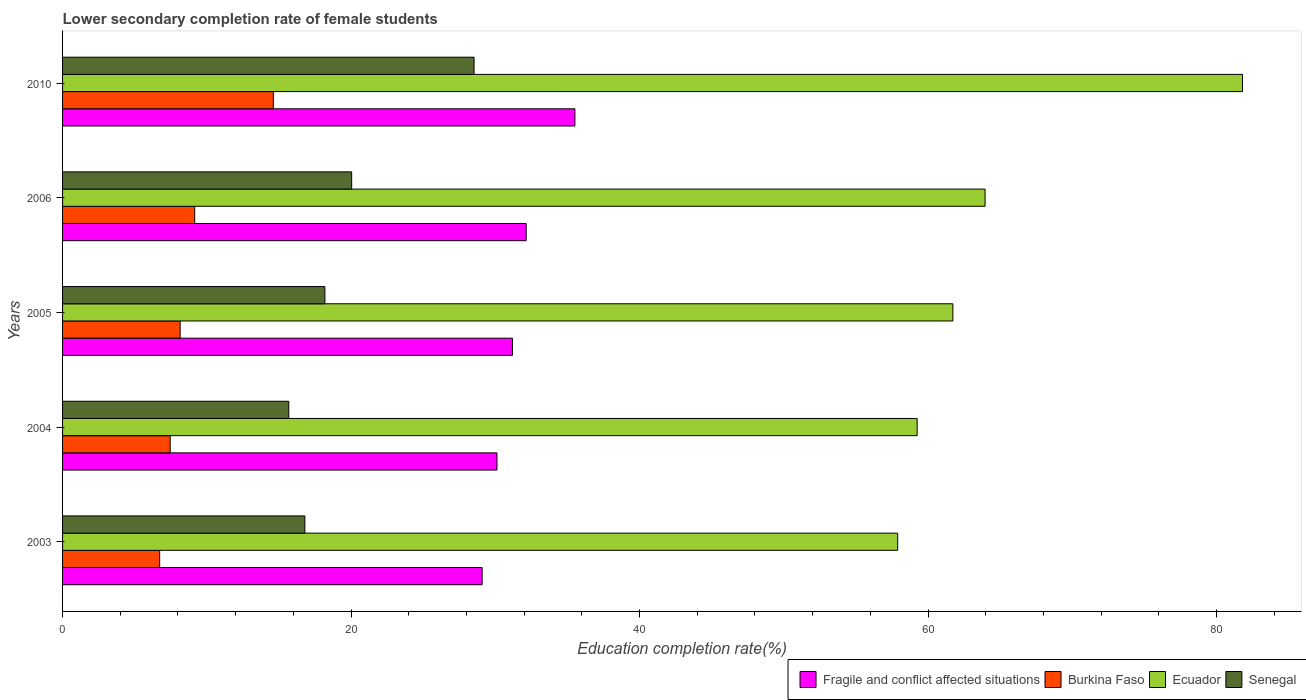How many different coloured bars are there?
Give a very brief answer. 4. How many groups of bars are there?
Your response must be concise. 5. Are the number of bars per tick equal to the number of legend labels?
Provide a succinct answer. Yes. How many bars are there on the 3rd tick from the bottom?
Your answer should be compact. 4. In how many cases, is the number of bars for a given year not equal to the number of legend labels?
Provide a succinct answer. 0. What is the lower secondary completion rate of female students in Burkina Faso in 2006?
Your answer should be very brief. 9.16. Across all years, what is the maximum lower secondary completion rate of female students in Burkina Faso?
Offer a very short reply. 14.61. Across all years, what is the minimum lower secondary completion rate of female students in Senegal?
Ensure brevity in your answer.  15.68. What is the total lower secondary completion rate of female students in Senegal in the graph?
Make the answer very short. 99.23. What is the difference between the lower secondary completion rate of female students in Burkina Faso in 2006 and that in 2010?
Offer a terse response. -5.45. What is the difference between the lower secondary completion rate of female students in Senegal in 2004 and the lower secondary completion rate of female students in Burkina Faso in 2006?
Keep it short and to the point. 6.52. What is the average lower secondary completion rate of female students in Burkina Faso per year?
Give a very brief answer. 9.22. In the year 2010, what is the difference between the lower secondary completion rate of female students in Burkina Faso and lower secondary completion rate of female students in Fragile and conflict affected situations?
Offer a terse response. -20.91. In how many years, is the lower secondary completion rate of female students in Senegal greater than 24 %?
Keep it short and to the point. 1. What is the ratio of the lower secondary completion rate of female students in Fragile and conflict affected situations in 2003 to that in 2010?
Give a very brief answer. 0.82. What is the difference between the highest and the second highest lower secondary completion rate of female students in Fragile and conflict affected situations?
Ensure brevity in your answer.  3.38. What is the difference between the highest and the lowest lower secondary completion rate of female students in Ecuador?
Your answer should be compact. 23.9. In how many years, is the lower secondary completion rate of female students in Senegal greater than the average lower secondary completion rate of female students in Senegal taken over all years?
Ensure brevity in your answer.  2. Is the sum of the lower secondary completion rate of female students in Burkina Faso in 2004 and 2006 greater than the maximum lower secondary completion rate of female students in Fragile and conflict affected situations across all years?
Make the answer very short. No. What does the 3rd bar from the top in 2010 represents?
Provide a short and direct response. Burkina Faso. What does the 1st bar from the bottom in 2003 represents?
Give a very brief answer. Fragile and conflict affected situations. How many bars are there?
Give a very brief answer. 20. What is the difference between two consecutive major ticks on the X-axis?
Make the answer very short. 20. Does the graph contain grids?
Your response must be concise. No. Where does the legend appear in the graph?
Offer a terse response. Bottom right. How are the legend labels stacked?
Offer a terse response. Horizontal. What is the title of the graph?
Your answer should be compact. Lower secondary completion rate of female students. Does "Guinea" appear as one of the legend labels in the graph?
Provide a short and direct response. No. What is the label or title of the X-axis?
Your answer should be very brief. Education completion rate(%). What is the Education completion rate(%) of Fragile and conflict affected situations in 2003?
Provide a succinct answer. 29.09. What is the Education completion rate(%) in Burkina Faso in 2003?
Your answer should be compact. 6.73. What is the Education completion rate(%) of Ecuador in 2003?
Offer a very short reply. 57.89. What is the Education completion rate(%) in Senegal in 2003?
Give a very brief answer. 16.8. What is the Education completion rate(%) in Fragile and conflict affected situations in 2004?
Keep it short and to the point. 30.11. What is the Education completion rate(%) of Burkina Faso in 2004?
Your response must be concise. 7.46. What is the Education completion rate(%) of Ecuador in 2004?
Your response must be concise. 59.24. What is the Education completion rate(%) of Senegal in 2004?
Give a very brief answer. 15.68. What is the Education completion rate(%) of Fragile and conflict affected situations in 2005?
Give a very brief answer. 31.19. What is the Education completion rate(%) in Burkina Faso in 2005?
Offer a very short reply. 8.15. What is the Education completion rate(%) in Ecuador in 2005?
Provide a succinct answer. 61.72. What is the Education completion rate(%) of Senegal in 2005?
Keep it short and to the point. 18.18. What is the Education completion rate(%) in Fragile and conflict affected situations in 2006?
Your response must be concise. 32.14. What is the Education completion rate(%) in Burkina Faso in 2006?
Make the answer very short. 9.16. What is the Education completion rate(%) in Ecuador in 2006?
Your answer should be very brief. 63.95. What is the Education completion rate(%) of Senegal in 2006?
Offer a very short reply. 20.04. What is the Education completion rate(%) of Fragile and conflict affected situations in 2010?
Offer a very short reply. 35.52. What is the Education completion rate(%) in Burkina Faso in 2010?
Make the answer very short. 14.61. What is the Education completion rate(%) of Ecuador in 2010?
Make the answer very short. 81.8. What is the Education completion rate(%) in Senegal in 2010?
Make the answer very short. 28.53. Across all years, what is the maximum Education completion rate(%) in Fragile and conflict affected situations?
Make the answer very short. 35.52. Across all years, what is the maximum Education completion rate(%) of Burkina Faso?
Your answer should be compact. 14.61. Across all years, what is the maximum Education completion rate(%) in Ecuador?
Offer a very short reply. 81.8. Across all years, what is the maximum Education completion rate(%) of Senegal?
Your answer should be very brief. 28.53. Across all years, what is the minimum Education completion rate(%) of Fragile and conflict affected situations?
Offer a terse response. 29.09. Across all years, what is the minimum Education completion rate(%) of Burkina Faso?
Provide a short and direct response. 6.73. Across all years, what is the minimum Education completion rate(%) of Ecuador?
Ensure brevity in your answer.  57.89. Across all years, what is the minimum Education completion rate(%) in Senegal?
Provide a short and direct response. 15.68. What is the total Education completion rate(%) in Fragile and conflict affected situations in the graph?
Make the answer very short. 158.04. What is the total Education completion rate(%) of Burkina Faso in the graph?
Make the answer very short. 46.11. What is the total Education completion rate(%) in Ecuador in the graph?
Your answer should be compact. 324.6. What is the total Education completion rate(%) of Senegal in the graph?
Your answer should be compact. 99.23. What is the difference between the Education completion rate(%) of Fragile and conflict affected situations in 2003 and that in 2004?
Offer a terse response. -1.03. What is the difference between the Education completion rate(%) in Burkina Faso in 2003 and that in 2004?
Your response must be concise. -0.73. What is the difference between the Education completion rate(%) of Ecuador in 2003 and that in 2004?
Make the answer very short. -1.35. What is the difference between the Education completion rate(%) of Senegal in 2003 and that in 2004?
Provide a succinct answer. 1.12. What is the difference between the Education completion rate(%) in Fragile and conflict affected situations in 2003 and that in 2005?
Offer a terse response. -2.1. What is the difference between the Education completion rate(%) in Burkina Faso in 2003 and that in 2005?
Provide a succinct answer. -1.42. What is the difference between the Education completion rate(%) of Ecuador in 2003 and that in 2005?
Give a very brief answer. -3.83. What is the difference between the Education completion rate(%) of Senegal in 2003 and that in 2005?
Provide a succinct answer. -1.39. What is the difference between the Education completion rate(%) of Fragile and conflict affected situations in 2003 and that in 2006?
Your response must be concise. -3.05. What is the difference between the Education completion rate(%) of Burkina Faso in 2003 and that in 2006?
Give a very brief answer. -2.43. What is the difference between the Education completion rate(%) of Ecuador in 2003 and that in 2006?
Provide a succinct answer. -6.06. What is the difference between the Education completion rate(%) in Senegal in 2003 and that in 2006?
Offer a terse response. -3.24. What is the difference between the Education completion rate(%) of Fragile and conflict affected situations in 2003 and that in 2010?
Offer a very short reply. -6.43. What is the difference between the Education completion rate(%) of Burkina Faso in 2003 and that in 2010?
Provide a short and direct response. -7.88. What is the difference between the Education completion rate(%) in Ecuador in 2003 and that in 2010?
Provide a short and direct response. -23.9. What is the difference between the Education completion rate(%) of Senegal in 2003 and that in 2010?
Your answer should be very brief. -11.73. What is the difference between the Education completion rate(%) of Fragile and conflict affected situations in 2004 and that in 2005?
Your response must be concise. -1.07. What is the difference between the Education completion rate(%) of Burkina Faso in 2004 and that in 2005?
Ensure brevity in your answer.  -0.69. What is the difference between the Education completion rate(%) in Ecuador in 2004 and that in 2005?
Offer a terse response. -2.48. What is the difference between the Education completion rate(%) in Senegal in 2004 and that in 2005?
Your response must be concise. -2.5. What is the difference between the Education completion rate(%) of Fragile and conflict affected situations in 2004 and that in 2006?
Offer a very short reply. -2.03. What is the difference between the Education completion rate(%) in Burkina Faso in 2004 and that in 2006?
Keep it short and to the point. -1.7. What is the difference between the Education completion rate(%) in Ecuador in 2004 and that in 2006?
Ensure brevity in your answer.  -4.71. What is the difference between the Education completion rate(%) of Senegal in 2004 and that in 2006?
Give a very brief answer. -4.36. What is the difference between the Education completion rate(%) of Fragile and conflict affected situations in 2004 and that in 2010?
Give a very brief answer. -5.4. What is the difference between the Education completion rate(%) in Burkina Faso in 2004 and that in 2010?
Keep it short and to the point. -7.15. What is the difference between the Education completion rate(%) in Ecuador in 2004 and that in 2010?
Your answer should be very brief. -22.55. What is the difference between the Education completion rate(%) in Senegal in 2004 and that in 2010?
Ensure brevity in your answer.  -12.84. What is the difference between the Education completion rate(%) of Fragile and conflict affected situations in 2005 and that in 2006?
Your response must be concise. -0.95. What is the difference between the Education completion rate(%) in Burkina Faso in 2005 and that in 2006?
Ensure brevity in your answer.  -1.01. What is the difference between the Education completion rate(%) of Ecuador in 2005 and that in 2006?
Your answer should be compact. -2.23. What is the difference between the Education completion rate(%) of Senegal in 2005 and that in 2006?
Your answer should be compact. -1.86. What is the difference between the Education completion rate(%) of Fragile and conflict affected situations in 2005 and that in 2010?
Your answer should be compact. -4.33. What is the difference between the Education completion rate(%) in Burkina Faso in 2005 and that in 2010?
Your answer should be very brief. -6.46. What is the difference between the Education completion rate(%) of Ecuador in 2005 and that in 2010?
Your answer should be very brief. -20.08. What is the difference between the Education completion rate(%) in Senegal in 2005 and that in 2010?
Your answer should be very brief. -10.34. What is the difference between the Education completion rate(%) of Fragile and conflict affected situations in 2006 and that in 2010?
Provide a succinct answer. -3.38. What is the difference between the Education completion rate(%) in Burkina Faso in 2006 and that in 2010?
Provide a short and direct response. -5.45. What is the difference between the Education completion rate(%) of Ecuador in 2006 and that in 2010?
Your response must be concise. -17.85. What is the difference between the Education completion rate(%) in Senegal in 2006 and that in 2010?
Give a very brief answer. -8.48. What is the difference between the Education completion rate(%) in Fragile and conflict affected situations in 2003 and the Education completion rate(%) in Burkina Faso in 2004?
Provide a short and direct response. 21.63. What is the difference between the Education completion rate(%) in Fragile and conflict affected situations in 2003 and the Education completion rate(%) in Ecuador in 2004?
Keep it short and to the point. -30.16. What is the difference between the Education completion rate(%) of Fragile and conflict affected situations in 2003 and the Education completion rate(%) of Senegal in 2004?
Keep it short and to the point. 13.4. What is the difference between the Education completion rate(%) in Burkina Faso in 2003 and the Education completion rate(%) in Ecuador in 2004?
Give a very brief answer. -52.51. What is the difference between the Education completion rate(%) of Burkina Faso in 2003 and the Education completion rate(%) of Senegal in 2004?
Your answer should be very brief. -8.95. What is the difference between the Education completion rate(%) in Ecuador in 2003 and the Education completion rate(%) in Senegal in 2004?
Provide a short and direct response. 42.21. What is the difference between the Education completion rate(%) in Fragile and conflict affected situations in 2003 and the Education completion rate(%) in Burkina Faso in 2005?
Keep it short and to the point. 20.93. What is the difference between the Education completion rate(%) in Fragile and conflict affected situations in 2003 and the Education completion rate(%) in Ecuador in 2005?
Your response must be concise. -32.63. What is the difference between the Education completion rate(%) of Fragile and conflict affected situations in 2003 and the Education completion rate(%) of Senegal in 2005?
Keep it short and to the point. 10.9. What is the difference between the Education completion rate(%) of Burkina Faso in 2003 and the Education completion rate(%) of Ecuador in 2005?
Your response must be concise. -54.99. What is the difference between the Education completion rate(%) in Burkina Faso in 2003 and the Education completion rate(%) in Senegal in 2005?
Make the answer very short. -11.45. What is the difference between the Education completion rate(%) of Ecuador in 2003 and the Education completion rate(%) of Senegal in 2005?
Provide a short and direct response. 39.71. What is the difference between the Education completion rate(%) of Fragile and conflict affected situations in 2003 and the Education completion rate(%) of Burkina Faso in 2006?
Provide a succinct answer. 19.93. What is the difference between the Education completion rate(%) in Fragile and conflict affected situations in 2003 and the Education completion rate(%) in Ecuador in 2006?
Ensure brevity in your answer.  -34.86. What is the difference between the Education completion rate(%) of Fragile and conflict affected situations in 2003 and the Education completion rate(%) of Senegal in 2006?
Offer a terse response. 9.05. What is the difference between the Education completion rate(%) in Burkina Faso in 2003 and the Education completion rate(%) in Ecuador in 2006?
Provide a short and direct response. -57.22. What is the difference between the Education completion rate(%) in Burkina Faso in 2003 and the Education completion rate(%) in Senegal in 2006?
Offer a very short reply. -13.31. What is the difference between the Education completion rate(%) of Ecuador in 2003 and the Education completion rate(%) of Senegal in 2006?
Your response must be concise. 37.85. What is the difference between the Education completion rate(%) in Fragile and conflict affected situations in 2003 and the Education completion rate(%) in Burkina Faso in 2010?
Offer a very short reply. 14.48. What is the difference between the Education completion rate(%) of Fragile and conflict affected situations in 2003 and the Education completion rate(%) of Ecuador in 2010?
Your answer should be compact. -52.71. What is the difference between the Education completion rate(%) of Fragile and conflict affected situations in 2003 and the Education completion rate(%) of Senegal in 2010?
Offer a very short reply. 0.56. What is the difference between the Education completion rate(%) of Burkina Faso in 2003 and the Education completion rate(%) of Ecuador in 2010?
Make the answer very short. -75.06. What is the difference between the Education completion rate(%) of Burkina Faso in 2003 and the Education completion rate(%) of Senegal in 2010?
Your answer should be very brief. -21.79. What is the difference between the Education completion rate(%) in Ecuador in 2003 and the Education completion rate(%) in Senegal in 2010?
Ensure brevity in your answer.  29.37. What is the difference between the Education completion rate(%) of Fragile and conflict affected situations in 2004 and the Education completion rate(%) of Burkina Faso in 2005?
Provide a succinct answer. 21.96. What is the difference between the Education completion rate(%) of Fragile and conflict affected situations in 2004 and the Education completion rate(%) of Ecuador in 2005?
Provide a short and direct response. -31.61. What is the difference between the Education completion rate(%) of Fragile and conflict affected situations in 2004 and the Education completion rate(%) of Senegal in 2005?
Keep it short and to the point. 11.93. What is the difference between the Education completion rate(%) in Burkina Faso in 2004 and the Education completion rate(%) in Ecuador in 2005?
Offer a very short reply. -54.26. What is the difference between the Education completion rate(%) of Burkina Faso in 2004 and the Education completion rate(%) of Senegal in 2005?
Your answer should be very brief. -10.72. What is the difference between the Education completion rate(%) in Ecuador in 2004 and the Education completion rate(%) in Senegal in 2005?
Provide a short and direct response. 41.06. What is the difference between the Education completion rate(%) in Fragile and conflict affected situations in 2004 and the Education completion rate(%) in Burkina Faso in 2006?
Keep it short and to the point. 20.95. What is the difference between the Education completion rate(%) of Fragile and conflict affected situations in 2004 and the Education completion rate(%) of Ecuador in 2006?
Your answer should be compact. -33.84. What is the difference between the Education completion rate(%) in Fragile and conflict affected situations in 2004 and the Education completion rate(%) in Senegal in 2006?
Offer a terse response. 10.07. What is the difference between the Education completion rate(%) of Burkina Faso in 2004 and the Education completion rate(%) of Ecuador in 2006?
Provide a short and direct response. -56.49. What is the difference between the Education completion rate(%) of Burkina Faso in 2004 and the Education completion rate(%) of Senegal in 2006?
Your answer should be very brief. -12.58. What is the difference between the Education completion rate(%) of Ecuador in 2004 and the Education completion rate(%) of Senegal in 2006?
Provide a short and direct response. 39.2. What is the difference between the Education completion rate(%) of Fragile and conflict affected situations in 2004 and the Education completion rate(%) of Burkina Faso in 2010?
Give a very brief answer. 15.5. What is the difference between the Education completion rate(%) in Fragile and conflict affected situations in 2004 and the Education completion rate(%) in Ecuador in 2010?
Offer a very short reply. -51.68. What is the difference between the Education completion rate(%) of Fragile and conflict affected situations in 2004 and the Education completion rate(%) of Senegal in 2010?
Make the answer very short. 1.59. What is the difference between the Education completion rate(%) of Burkina Faso in 2004 and the Education completion rate(%) of Ecuador in 2010?
Your answer should be compact. -74.34. What is the difference between the Education completion rate(%) of Burkina Faso in 2004 and the Education completion rate(%) of Senegal in 2010?
Your response must be concise. -21.07. What is the difference between the Education completion rate(%) of Ecuador in 2004 and the Education completion rate(%) of Senegal in 2010?
Ensure brevity in your answer.  30.72. What is the difference between the Education completion rate(%) of Fragile and conflict affected situations in 2005 and the Education completion rate(%) of Burkina Faso in 2006?
Keep it short and to the point. 22.02. What is the difference between the Education completion rate(%) in Fragile and conflict affected situations in 2005 and the Education completion rate(%) in Ecuador in 2006?
Provide a short and direct response. -32.76. What is the difference between the Education completion rate(%) of Fragile and conflict affected situations in 2005 and the Education completion rate(%) of Senegal in 2006?
Your response must be concise. 11.14. What is the difference between the Education completion rate(%) in Burkina Faso in 2005 and the Education completion rate(%) in Ecuador in 2006?
Provide a short and direct response. -55.8. What is the difference between the Education completion rate(%) of Burkina Faso in 2005 and the Education completion rate(%) of Senegal in 2006?
Your response must be concise. -11.89. What is the difference between the Education completion rate(%) of Ecuador in 2005 and the Education completion rate(%) of Senegal in 2006?
Make the answer very short. 41.68. What is the difference between the Education completion rate(%) of Fragile and conflict affected situations in 2005 and the Education completion rate(%) of Burkina Faso in 2010?
Provide a short and direct response. 16.58. What is the difference between the Education completion rate(%) of Fragile and conflict affected situations in 2005 and the Education completion rate(%) of Ecuador in 2010?
Give a very brief answer. -50.61. What is the difference between the Education completion rate(%) of Fragile and conflict affected situations in 2005 and the Education completion rate(%) of Senegal in 2010?
Ensure brevity in your answer.  2.66. What is the difference between the Education completion rate(%) in Burkina Faso in 2005 and the Education completion rate(%) in Ecuador in 2010?
Offer a terse response. -73.64. What is the difference between the Education completion rate(%) in Burkina Faso in 2005 and the Education completion rate(%) in Senegal in 2010?
Your response must be concise. -20.37. What is the difference between the Education completion rate(%) in Ecuador in 2005 and the Education completion rate(%) in Senegal in 2010?
Keep it short and to the point. 33.19. What is the difference between the Education completion rate(%) in Fragile and conflict affected situations in 2006 and the Education completion rate(%) in Burkina Faso in 2010?
Make the answer very short. 17.53. What is the difference between the Education completion rate(%) of Fragile and conflict affected situations in 2006 and the Education completion rate(%) of Ecuador in 2010?
Give a very brief answer. -49.66. What is the difference between the Education completion rate(%) of Fragile and conflict affected situations in 2006 and the Education completion rate(%) of Senegal in 2010?
Your response must be concise. 3.61. What is the difference between the Education completion rate(%) of Burkina Faso in 2006 and the Education completion rate(%) of Ecuador in 2010?
Make the answer very short. -72.63. What is the difference between the Education completion rate(%) of Burkina Faso in 2006 and the Education completion rate(%) of Senegal in 2010?
Your answer should be compact. -19.36. What is the difference between the Education completion rate(%) of Ecuador in 2006 and the Education completion rate(%) of Senegal in 2010?
Your response must be concise. 35.42. What is the average Education completion rate(%) of Fragile and conflict affected situations per year?
Your response must be concise. 31.61. What is the average Education completion rate(%) of Burkina Faso per year?
Your response must be concise. 9.22. What is the average Education completion rate(%) in Ecuador per year?
Ensure brevity in your answer.  64.92. What is the average Education completion rate(%) in Senegal per year?
Make the answer very short. 19.85. In the year 2003, what is the difference between the Education completion rate(%) in Fragile and conflict affected situations and Education completion rate(%) in Burkina Faso?
Offer a terse response. 22.35. In the year 2003, what is the difference between the Education completion rate(%) of Fragile and conflict affected situations and Education completion rate(%) of Ecuador?
Your answer should be very brief. -28.81. In the year 2003, what is the difference between the Education completion rate(%) in Fragile and conflict affected situations and Education completion rate(%) in Senegal?
Provide a succinct answer. 12.29. In the year 2003, what is the difference between the Education completion rate(%) in Burkina Faso and Education completion rate(%) in Ecuador?
Give a very brief answer. -51.16. In the year 2003, what is the difference between the Education completion rate(%) in Burkina Faso and Education completion rate(%) in Senegal?
Your response must be concise. -10.07. In the year 2003, what is the difference between the Education completion rate(%) in Ecuador and Education completion rate(%) in Senegal?
Offer a terse response. 41.1. In the year 2004, what is the difference between the Education completion rate(%) in Fragile and conflict affected situations and Education completion rate(%) in Burkina Faso?
Offer a very short reply. 22.65. In the year 2004, what is the difference between the Education completion rate(%) in Fragile and conflict affected situations and Education completion rate(%) in Ecuador?
Provide a short and direct response. -29.13. In the year 2004, what is the difference between the Education completion rate(%) in Fragile and conflict affected situations and Education completion rate(%) in Senegal?
Your response must be concise. 14.43. In the year 2004, what is the difference between the Education completion rate(%) in Burkina Faso and Education completion rate(%) in Ecuador?
Your answer should be very brief. -51.78. In the year 2004, what is the difference between the Education completion rate(%) of Burkina Faso and Education completion rate(%) of Senegal?
Your answer should be very brief. -8.22. In the year 2004, what is the difference between the Education completion rate(%) in Ecuador and Education completion rate(%) in Senegal?
Your answer should be very brief. 43.56. In the year 2005, what is the difference between the Education completion rate(%) of Fragile and conflict affected situations and Education completion rate(%) of Burkina Faso?
Provide a succinct answer. 23.03. In the year 2005, what is the difference between the Education completion rate(%) of Fragile and conflict affected situations and Education completion rate(%) of Ecuador?
Your answer should be compact. -30.53. In the year 2005, what is the difference between the Education completion rate(%) of Fragile and conflict affected situations and Education completion rate(%) of Senegal?
Keep it short and to the point. 13. In the year 2005, what is the difference between the Education completion rate(%) in Burkina Faso and Education completion rate(%) in Ecuador?
Make the answer very short. -53.57. In the year 2005, what is the difference between the Education completion rate(%) of Burkina Faso and Education completion rate(%) of Senegal?
Offer a terse response. -10.03. In the year 2005, what is the difference between the Education completion rate(%) of Ecuador and Education completion rate(%) of Senegal?
Provide a succinct answer. 43.53. In the year 2006, what is the difference between the Education completion rate(%) in Fragile and conflict affected situations and Education completion rate(%) in Burkina Faso?
Your answer should be very brief. 22.98. In the year 2006, what is the difference between the Education completion rate(%) in Fragile and conflict affected situations and Education completion rate(%) in Ecuador?
Ensure brevity in your answer.  -31.81. In the year 2006, what is the difference between the Education completion rate(%) in Fragile and conflict affected situations and Education completion rate(%) in Senegal?
Provide a short and direct response. 12.1. In the year 2006, what is the difference between the Education completion rate(%) in Burkina Faso and Education completion rate(%) in Ecuador?
Offer a terse response. -54.79. In the year 2006, what is the difference between the Education completion rate(%) of Burkina Faso and Education completion rate(%) of Senegal?
Ensure brevity in your answer.  -10.88. In the year 2006, what is the difference between the Education completion rate(%) in Ecuador and Education completion rate(%) in Senegal?
Offer a very short reply. 43.91. In the year 2010, what is the difference between the Education completion rate(%) in Fragile and conflict affected situations and Education completion rate(%) in Burkina Faso?
Keep it short and to the point. 20.91. In the year 2010, what is the difference between the Education completion rate(%) in Fragile and conflict affected situations and Education completion rate(%) in Ecuador?
Keep it short and to the point. -46.28. In the year 2010, what is the difference between the Education completion rate(%) of Fragile and conflict affected situations and Education completion rate(%) of Senegal?
Ensure brevity in your answer.  6.99. In the year 2010, what is the difference between the Education completion rate(%) of Burkina Faso and Education completion rate(%) of Ecuador?
Provide a short and direct response. -67.19. In the year 2010, what is the difference between the Education completion rate(%) of Burkina Faso and Education completion rate(%) of Senegal?
Keep it short and to the point. -13.92. In the year 2010, what is the difference between the Education completion rate(%) of Ecuador and Education completion rate(%) of Senegal?
Ensure brevity in your answer.  53.27. What is the ratio of the Education completion rate(%) in Fragile and conflict affected situations in 2003 to that in 2004?
Ensure brevity in your answer.  0.97. What is the ratio of the Education completion rate(%) of Burkina Faso in 2003 to that in 2004?
Give a very brief answer. 0.9. What is the ratio of the Education completion rate(%) of Ecuador in 2003 to that in 2004?
Offer a terse response. 0.98. What is the ratio of the Education completion rate(%) in Senegal in 2003 to that in 2004?
Your response must be concise. 1.07. What is the ratio of the Education completion rate(%) of Fragile and conflict affected situations in 2003 to that in 2005?
Your answer should be very brief. 0.93. What is the ratio of the Education completion rate(%) in Burkina Faso in 2003 to that in 2005?
Give a very brief answer. 0.83. What is the ratio of the Education completion rate(%) of Ecuador in 2003 to that in 2005?
Your answer should be very brief. 0.94. What is the ratio of the Education completion rate(%) in Senegal in 2003 to that in 2005?
Provide a succinct answer. 0.92. What is the ratio of the Education completion rate(%) in Fragile and conflict affected situations in 2003 to that in 2006?
Offer a terse response. 0.91. What is the ratio of the Education completion rate(%) in Burkina Faso in 2003 to that in 2006?
Ensure brevity in your answer.  0.73. What is the ratio of the Education completion rate(%) of Ecuador in 2003 to that in 2006?
Give a very brief answer. 0.91. What is the ratio of the Education completion rate(%) in Senegal in 2003 to that in 2006?
Provide a succinct answer. 0.84. What is the ratio of the Education completion rate(%) of Fragile and conflict affected situations in 2003 to that in 2010?
Offer a terse response. 0.82. What is the ratio of the Education completion rate(%) in Burkina Faso in 2003 to that in 2010?
Your response must be concise. 0.46. What is the ratio of the Education completion rate(%) of Ecuador in 2003 to that in 2010?
Provide a succinct answer. 0.71. What is the ratio of the Education completion rate(%) in Senegal in 2003 to that in 2010?
Your answer should be compact. 0.59. What is the ratio of the Education completion rate(%) in Fragile and conflict affected situations in 2004 to that in 2005?
Provide a succinct answer. 0.97. What is the ratio of the Education completion rate(%) of Burkina Faso in 2004 to that in 2005?
Offer a terse response. 0.92. What is the ratio of the Education completion rate(%) of Ecuador in 2004 to that in 2005?
Offer a very short reply. 0.96. What is the ratio of the Education completion rate(%) of Senegal in 2004 to that in 2005?
Make the answer very short. 0.86. What is the ratio of the Education completion rate(%) of Fragile and conflict affected situations in 2004 to that in 2006?
Your response must be concise. 0.94. What is the ratio of the Education completion rate(%) of Burkina Faso in 2004 to that in 2006?
Your answer should be compact. 0.81. What is the ratio of the Education completion rate(%) of Ecuador in 2004 to that in 2006?
Provide a succinct answer. 0.93. What is the ratio of the Education completion rate(%) of Senegal in 2004 to that in 2006?
Keep it short and to the point. 0.78. What is the ratio of the Education completion rate(%) of Fragile and conflict affected situations in 2004 to that in 2010?
Offer a terse response. 0.85. What is the ratio of the Education completion rate(%) of Burkina Faso in 2004 to that in 2010?
Keep it short and to the point. 0.51. What is the ratio of the Education completion rate(%) in Ecuador in 2004 to that in 2010?
Your answer should be compact. 0.72. What is the ratio of the Education completion rate(%) of Senegal in 2004 to that in 2010?
Your answer should be compact. 0.55. What is the ratio of the Education completion rate(%) of Fragile and conflict affected situations in 2005 to that in 2006?
Ensure brevity in your answer.  0.97. What is the ratio of the Education completion rate(%) in Burkina Faso in 2005 to that in 2006?
Make the answer very short. 0.89. What is the ratio of the Education completion rate(%) in Ecuador in 2005 to that in 2006?
Provide a succinct answer. 0.97. What is the ratio of the Education completion rate(%) of Senegal in 2005 to that in 2006?
Provide a short and direct response. 0.91. What is the ratio of the Education completion rate(%) of Fragile and conflict affected situations in 2005 to that in 2010?
Ensure brevity in your answer.  0.88. What is the ratio of the Education completion rate(%) of Burkina Faso in 2005 to that in 2010?
Provide a short and direct response. 0.56. What is the ratio of the Education completion rate(%) of Ecuador in 2005 to that in 2010?
Your answer should be compact. 0.75. What is the ratio of the Education completion rate(%) in Senegal in 2005 to that in 2010?
Provide a succinct answer. 0.64. What is the ratio of the Education completion rate(%) of Fragile and conflict affected situations in 2006 to that in 2010?
Make the answer very short. 0.9. What is the ratio of the Education completion rate(%) of Burkina Faso in 2006 to that in 2010?
Keep it short and to the point. 0.63. What is the ratio of the Education completion rate(%) of Ecuador in 2006 to that in 2010?
Give a very brief answer. 0.78. What is the ratio of the Education completion rate(%) in Senegal in 2006 to that in 2010?
Provide a succinct answer. 0.7. What is the difference between the highest and the second highest Education completion rate(%) of Fragile and conflict affected situations?
Give a very brief answer. 3.38. What is the difference between the highest and the second highest Education completion rate(%) in Burkina Faso?
Your answer should be very brief. 5.45. What is the difference between the highest and the second highest Education completion rate(%) of Ecuador?
Your answer should be very brief. 17.85. What is the difference between the highest and the second highest Education completion rate(%) of Senegal?
Offer a very short reply. 8.48. What is the difference between the highest and the lowest Education completion rate(%) in Fragile and conflict affected situations?
Provide a short and direct response. 6.43. What is the difference between the highest and the lowest Education completion rate(%) in Burkina Faso?
Your answer should be compact. 7.88. What is the difference between the highest and the lowest Education completion rate(%) in Ecuador?
Provide a short and direct response. 23.9. What is the difference between the highest and the lowest Education completion rate(%) of Senegal?
Your response must be concise. 12.84. 